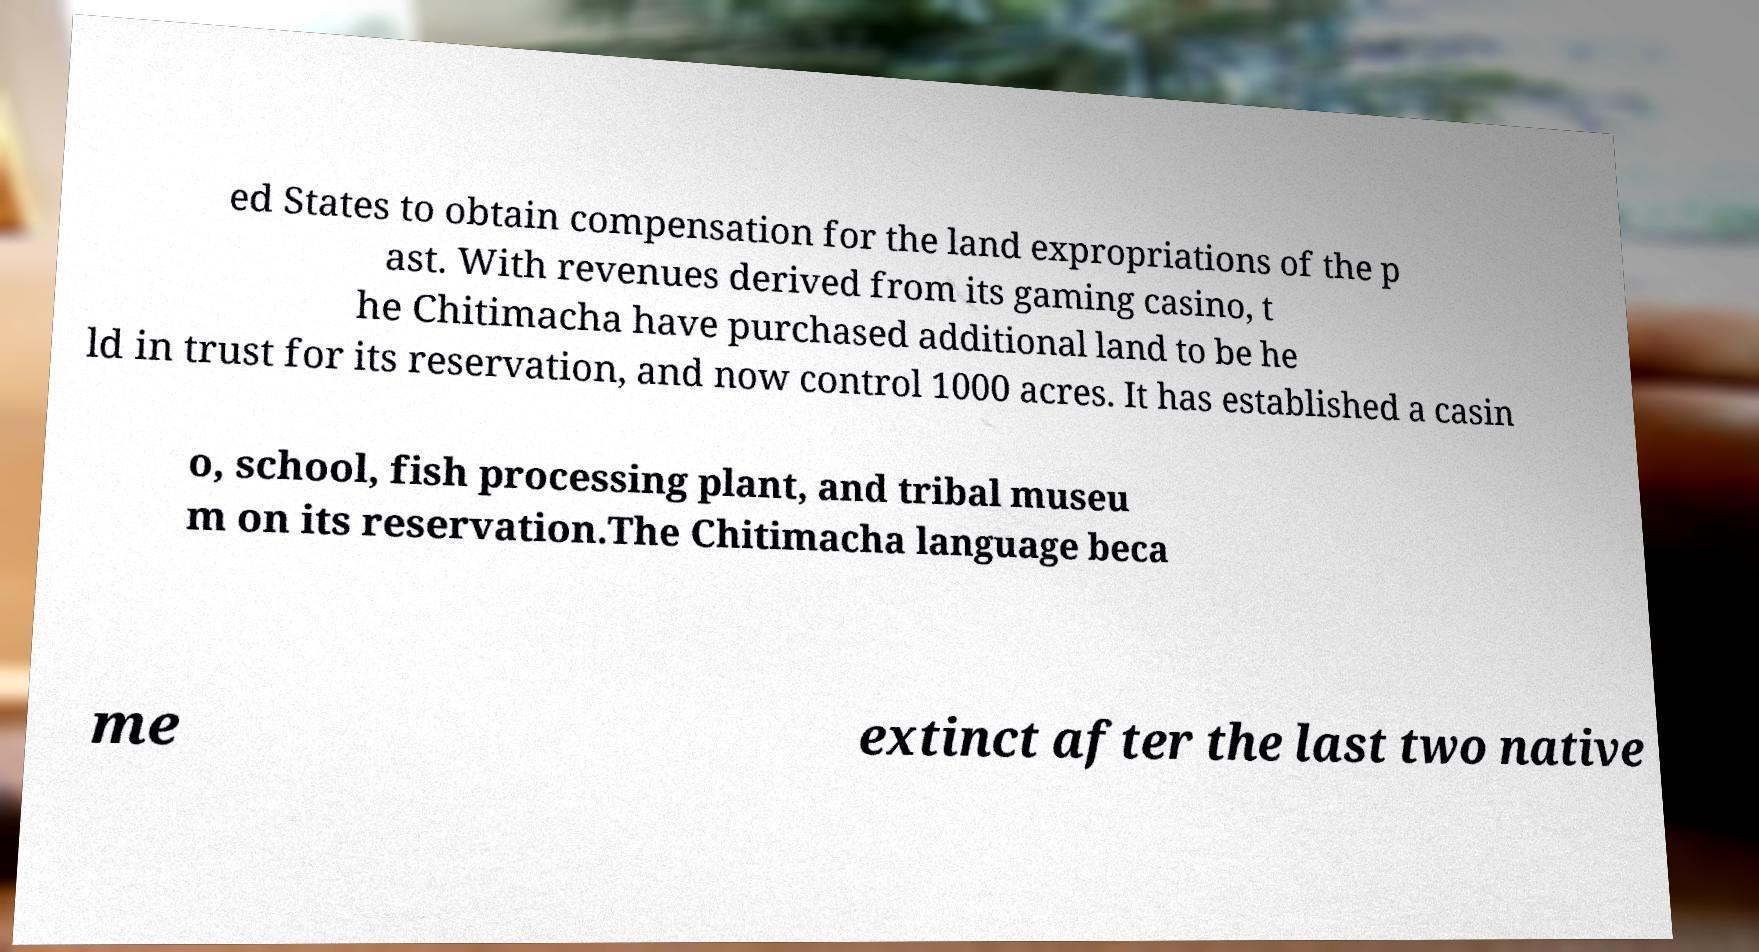Can you accurately transcribe the text from the provided image for me? ed States to obtain compensation for the land expropriations of the p ast. With revenues derived from its gaming casino, t he Chitimacha have purchased additional land to be he ld in trust for its reservation, and now control 1000 acres. It has established a casin o, school, fish processing plant, and tribal museu m on its reservation.The Chitimacha language beca me extinct after the last two native 